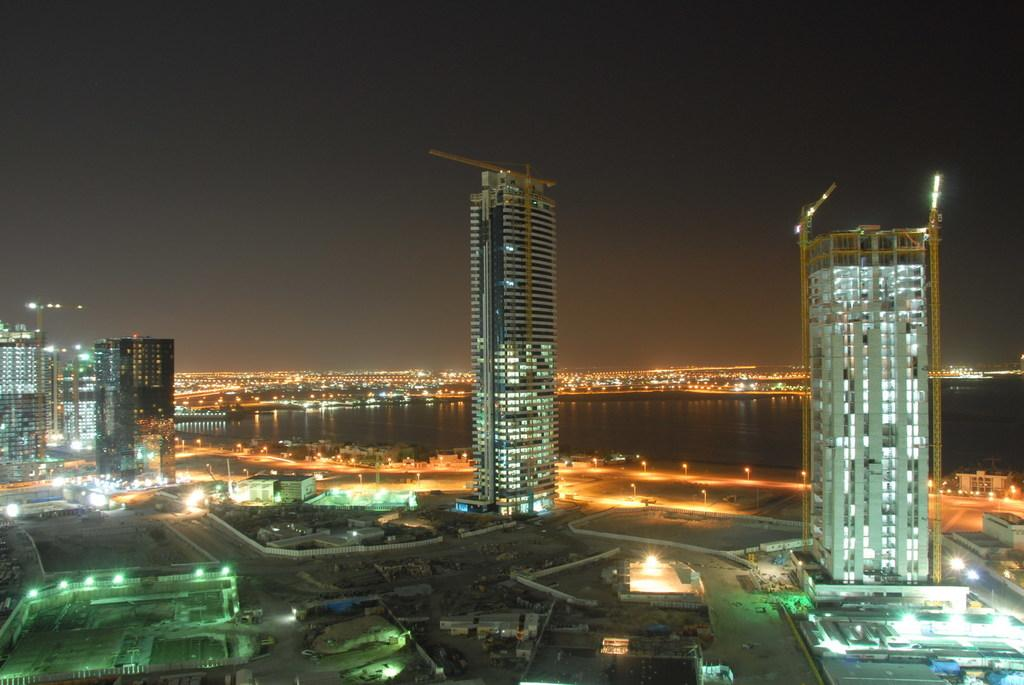What type of structures can be seen in the image? There are buildings in the image. What else is visible in the image besides the buildings? There are lights and a river visible in the image. What part of the natural environment is present in the image? The sky is visible in the image. What type of corn is growing near the river in the image? There is no corn present in the image; it features buildings, lights, a river, and the sky. 